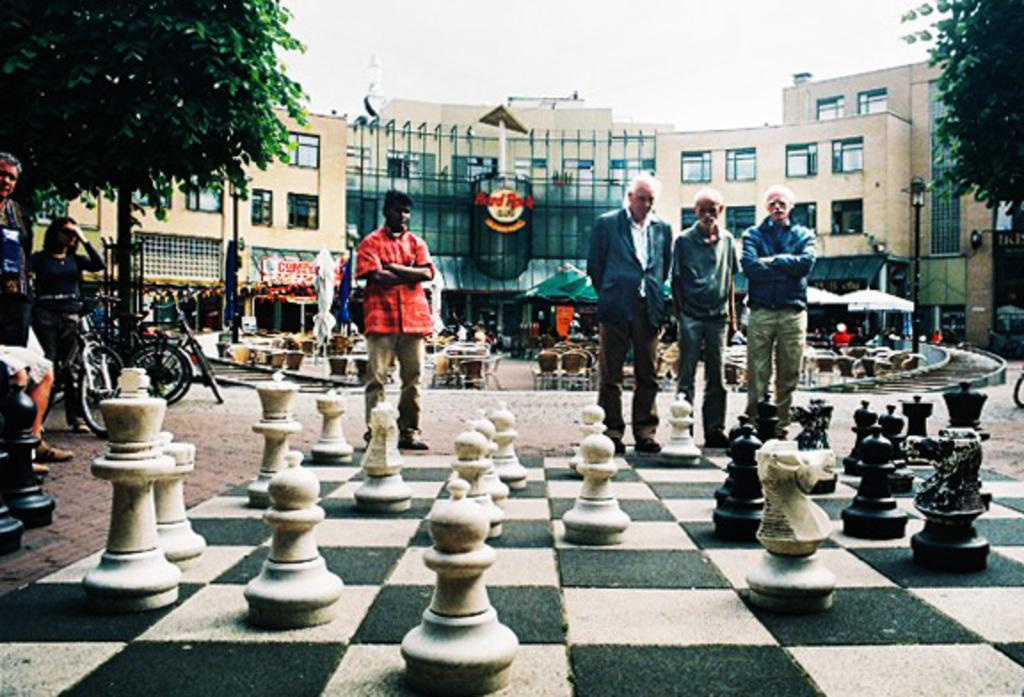<image>
Offer a succinct explanation of the picture presented. A group of men standing in front of  Hard Rock Cafe building 